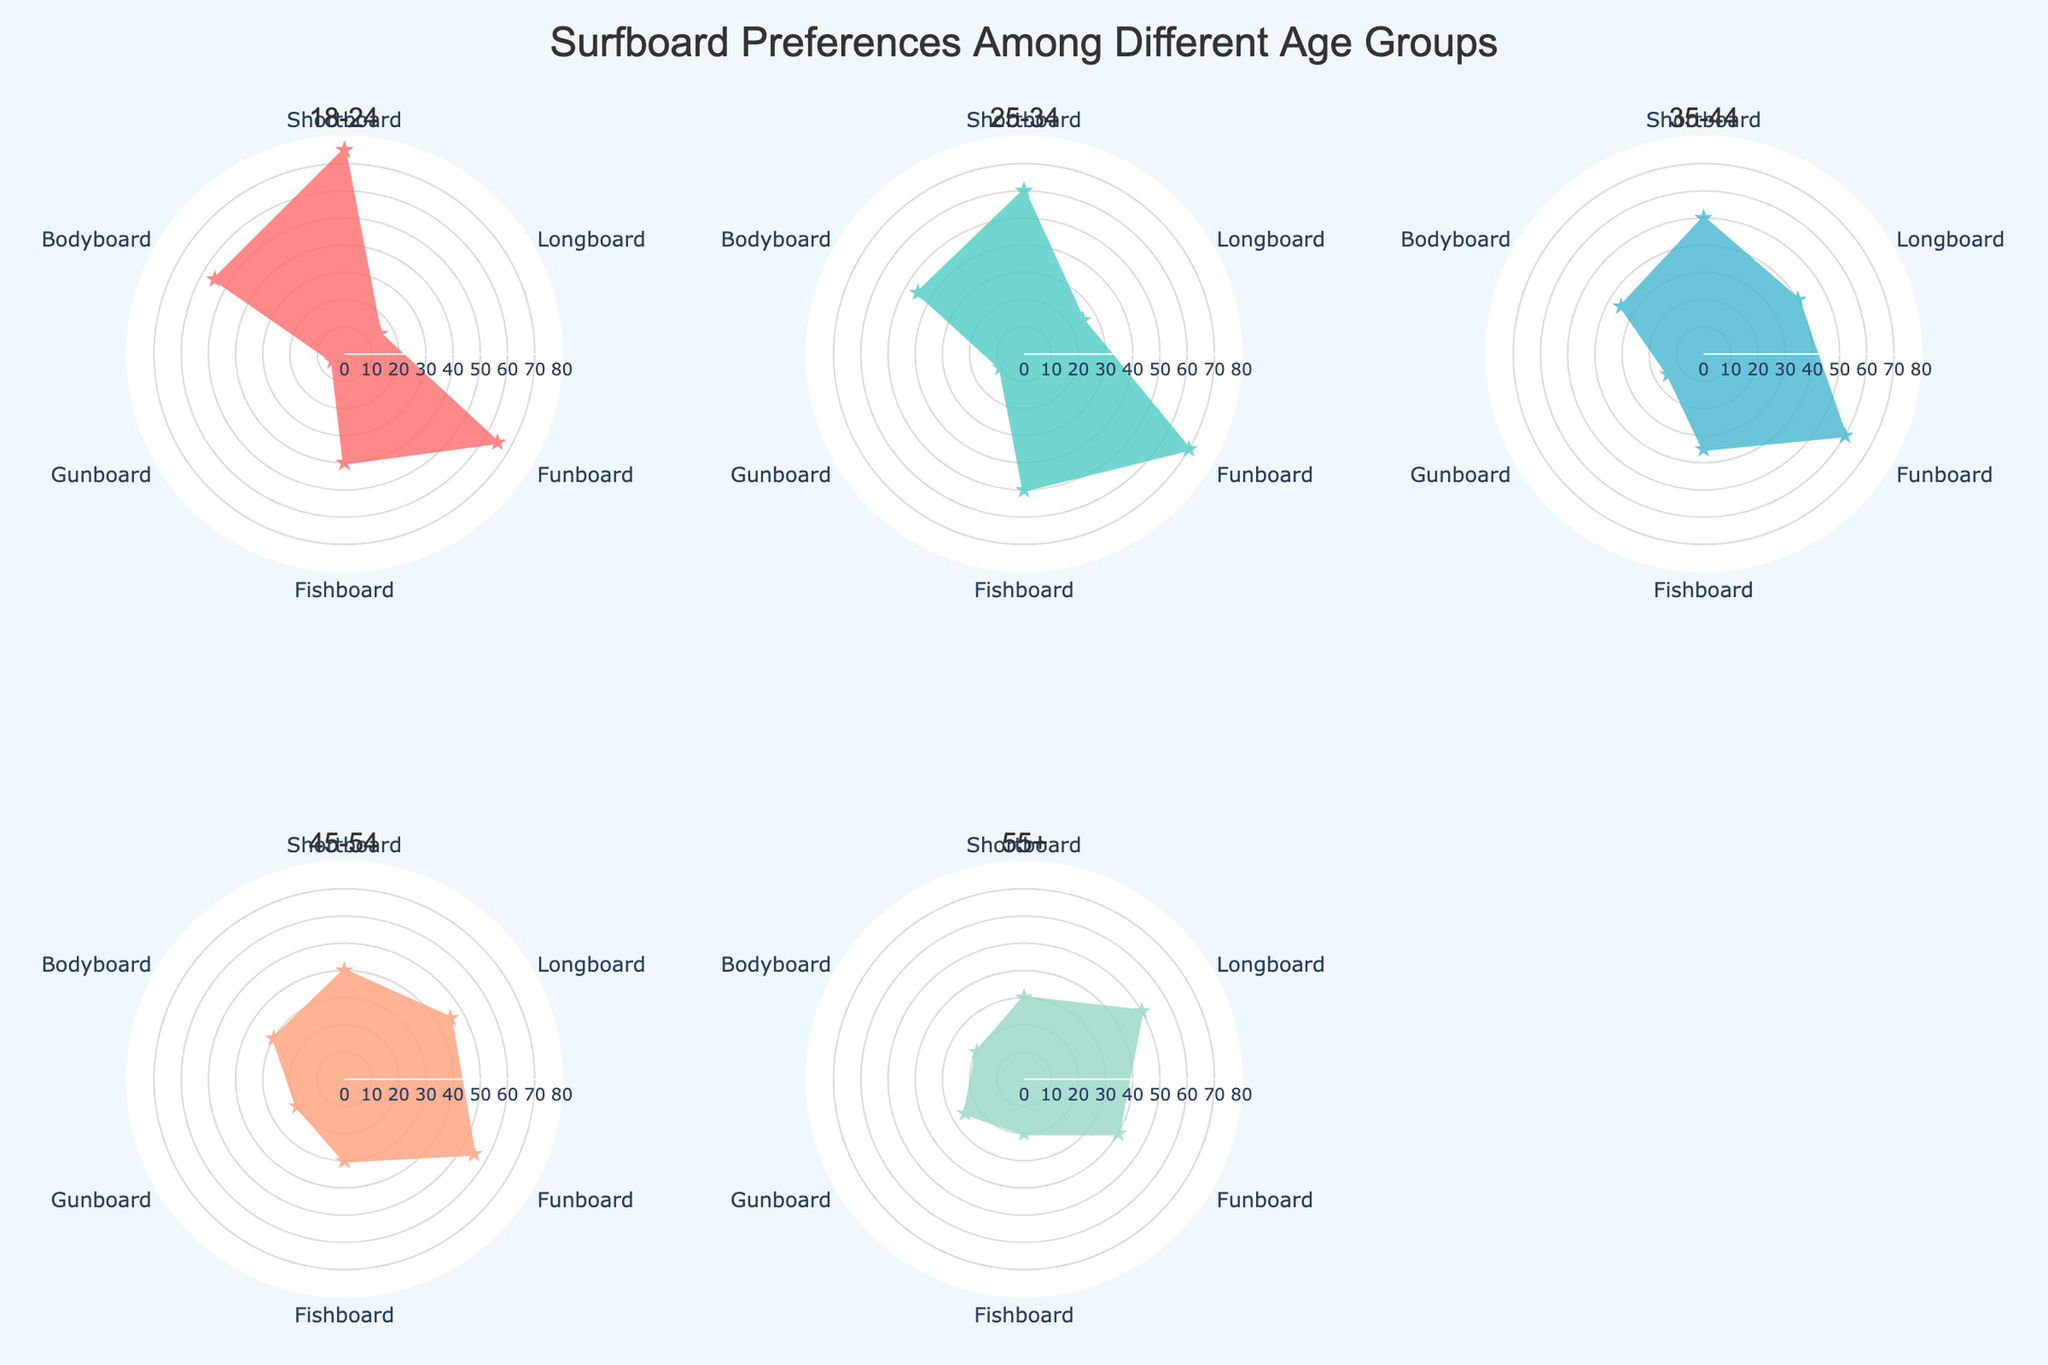What's the title of the figure? The title is centered at the top of the figure in a larger font and states what the chart is about.
Answer: Surfboard Preferences Among Different Age Groups Which age group has the highest preference for shortboards? By looking at each subplot, the values for shortboard preference are evident. Compare these values for each age group.
Answer: 18-24 What is the preference value for bodyboards among the 55+ age group? In the subplot for the 55+ age group, locate the value indicated on the bodyboard axis
Answer: 20 Which age group shows the least preference for gunboards? Compare the values on the gunboard axis for each age group and find the smallest one.
Answer: 18-24 For the 35-44 age group, are funboards preferred over fishboards? By looking at the values for funboards and fishboards in the subplot for the 35-44 age group, compare them.
Answer: Yes What's the difference in longboard preference between the 25-34 and 45-54 age groups? Locate the preference values of longboards in the subplots for the 25-34 and 45-54 age groups and subtract one from the other (45 - 25).
Answer: 20 Which age group has the most balanced preferences across all surfboard types (i.e., values are closest to each other)? Compare the range of values (difference between highest and lowest) for each age group. The group with the smallest range is the most balanced.
Answer: 18-24 Sum the preferences of bodyboards, fishboards, and funboards for the 18-24 age group. Add values for bodyboards (55), fishboards (40), and funboards (65) for the 18-24 age group (55 + 40 + 65)
Answer: 160 Which age group prefers fishboards more than bodyboards? Compare preferences for fishboards and bodyboards in each age group to identify which age groups have a higher fishboard preference.
Answer: 18-24, 25-34, 35-44, 45-54 Is the preference for funboards consistently increasing with increasing age groups? Scan through the funboard preference values for each successive age group and see if each value is higher than the previous one.
Answer: No 